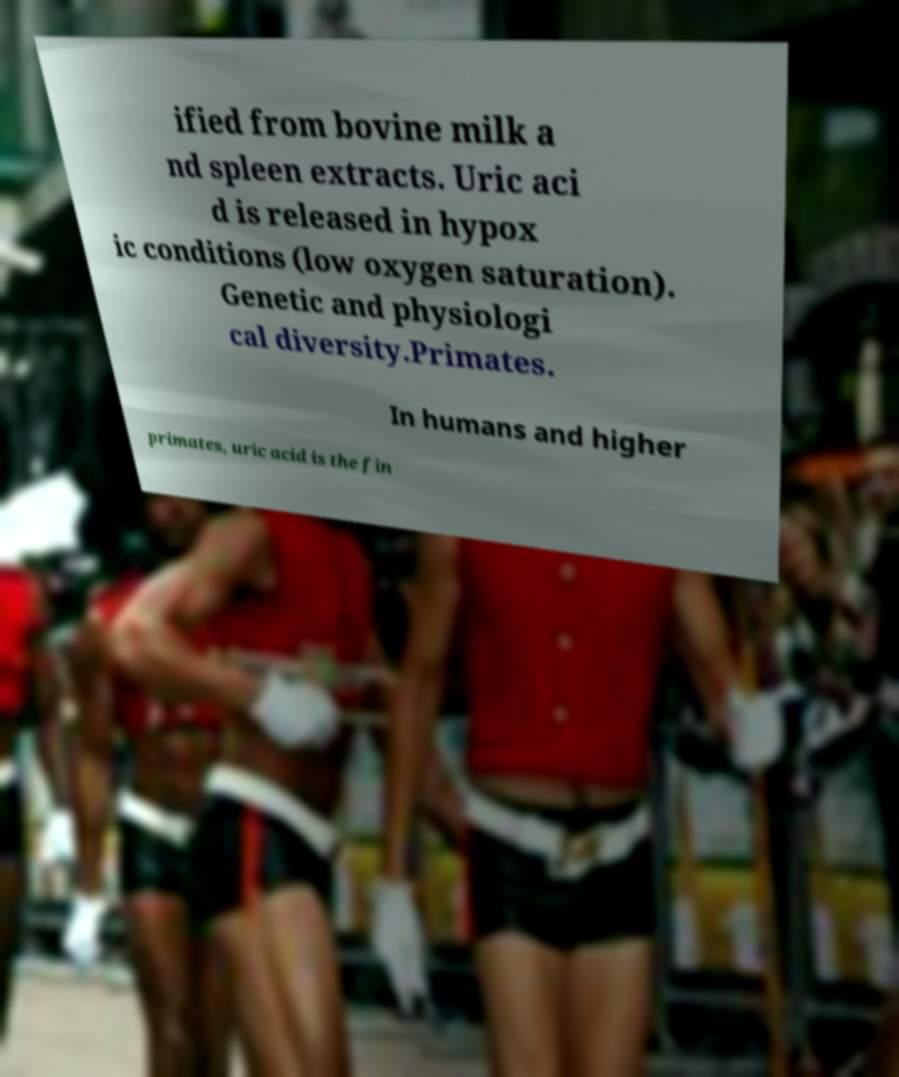Can you read and provide the text displayed in the image?This photo seems to have some interesting text. Can you extract and type it out for me? ified from bovine milk a nd spleen extracts. Uric aci d is released in hypox ic conditions (low oxygen saturation). Genetic and physiologi cal diversity.Primates. In humans and higher primates, uric acid is the fin 